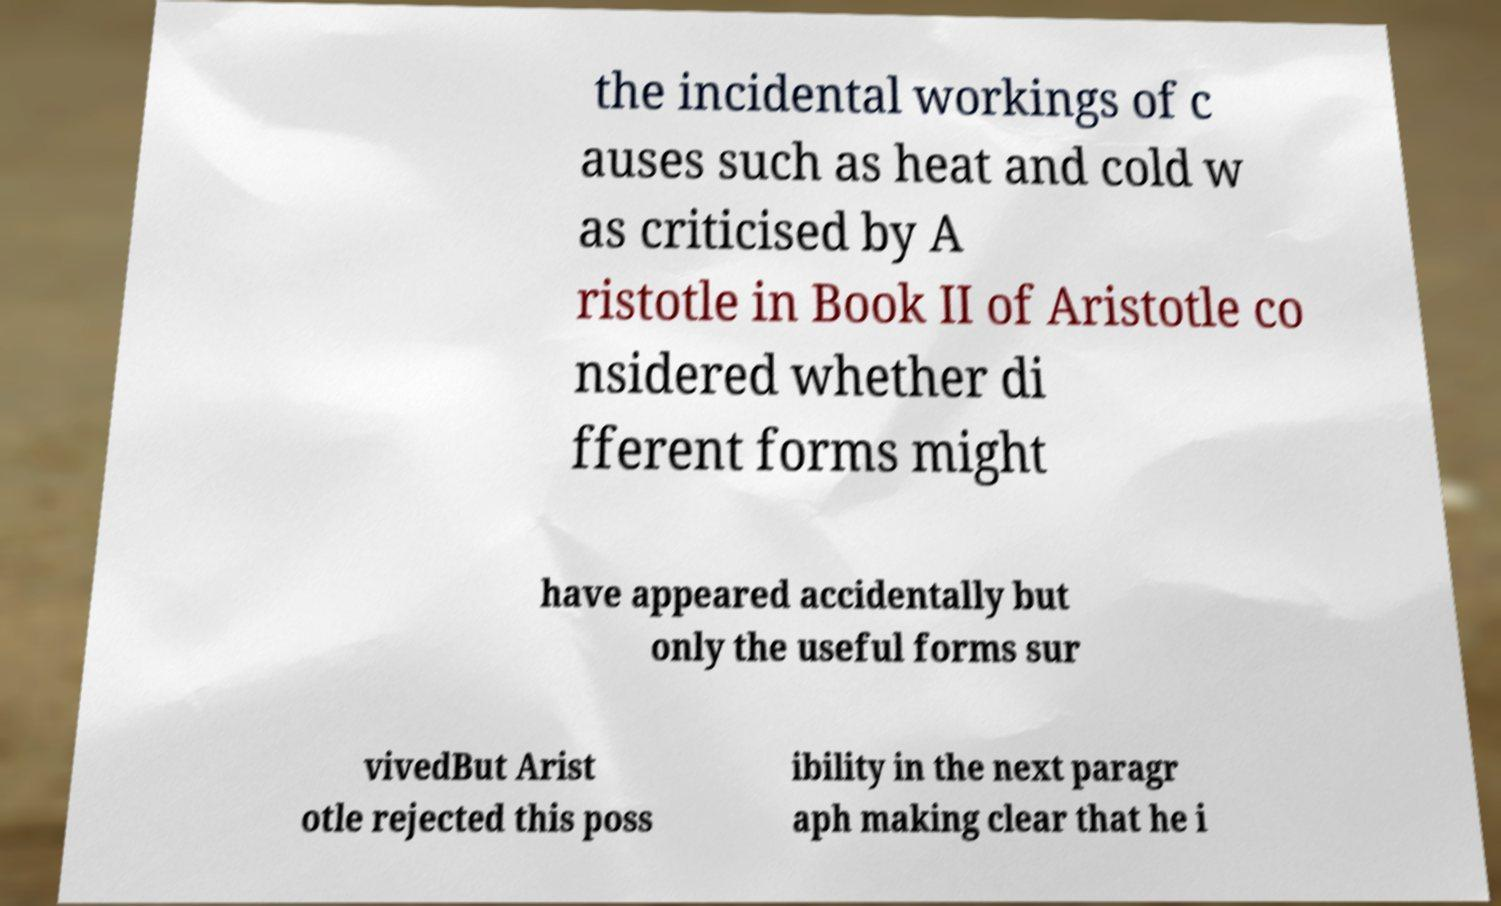Please read and relay the text visible in this image. What does it say? the incidental workings of c auses such as heat and cold w as criticised by A ristotle in Book II of Aristotle co nsidered whether di fferent forms might have appeared accidentally but only the useful forms sur vivedBut Arist otle rejected this poss ibility in the next paragr aph making clear that he i 